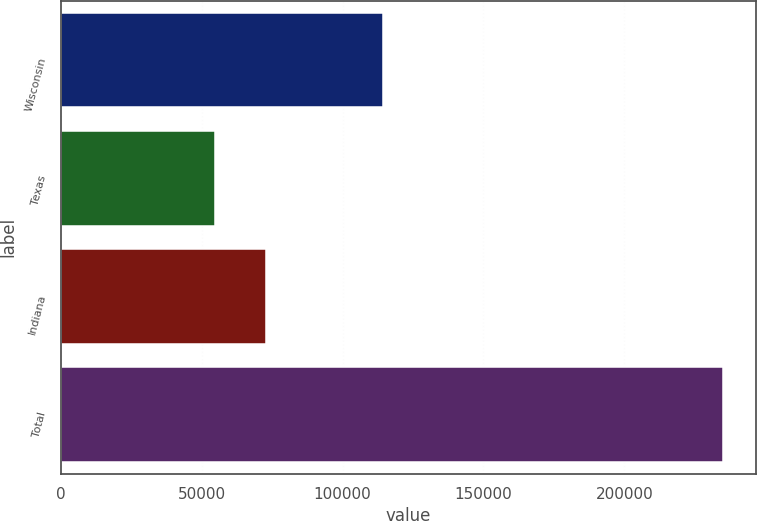Convert chart. <chart><loc_0><loc_0><loc_500><loc_500><bar_chart><fcel>Wisconsin<fcel>Texas<fcel>Indiana<fcel>Total<nl><fcel>114300<fcel>54900<fcel>72920<fcel>235100<nl></chart> 